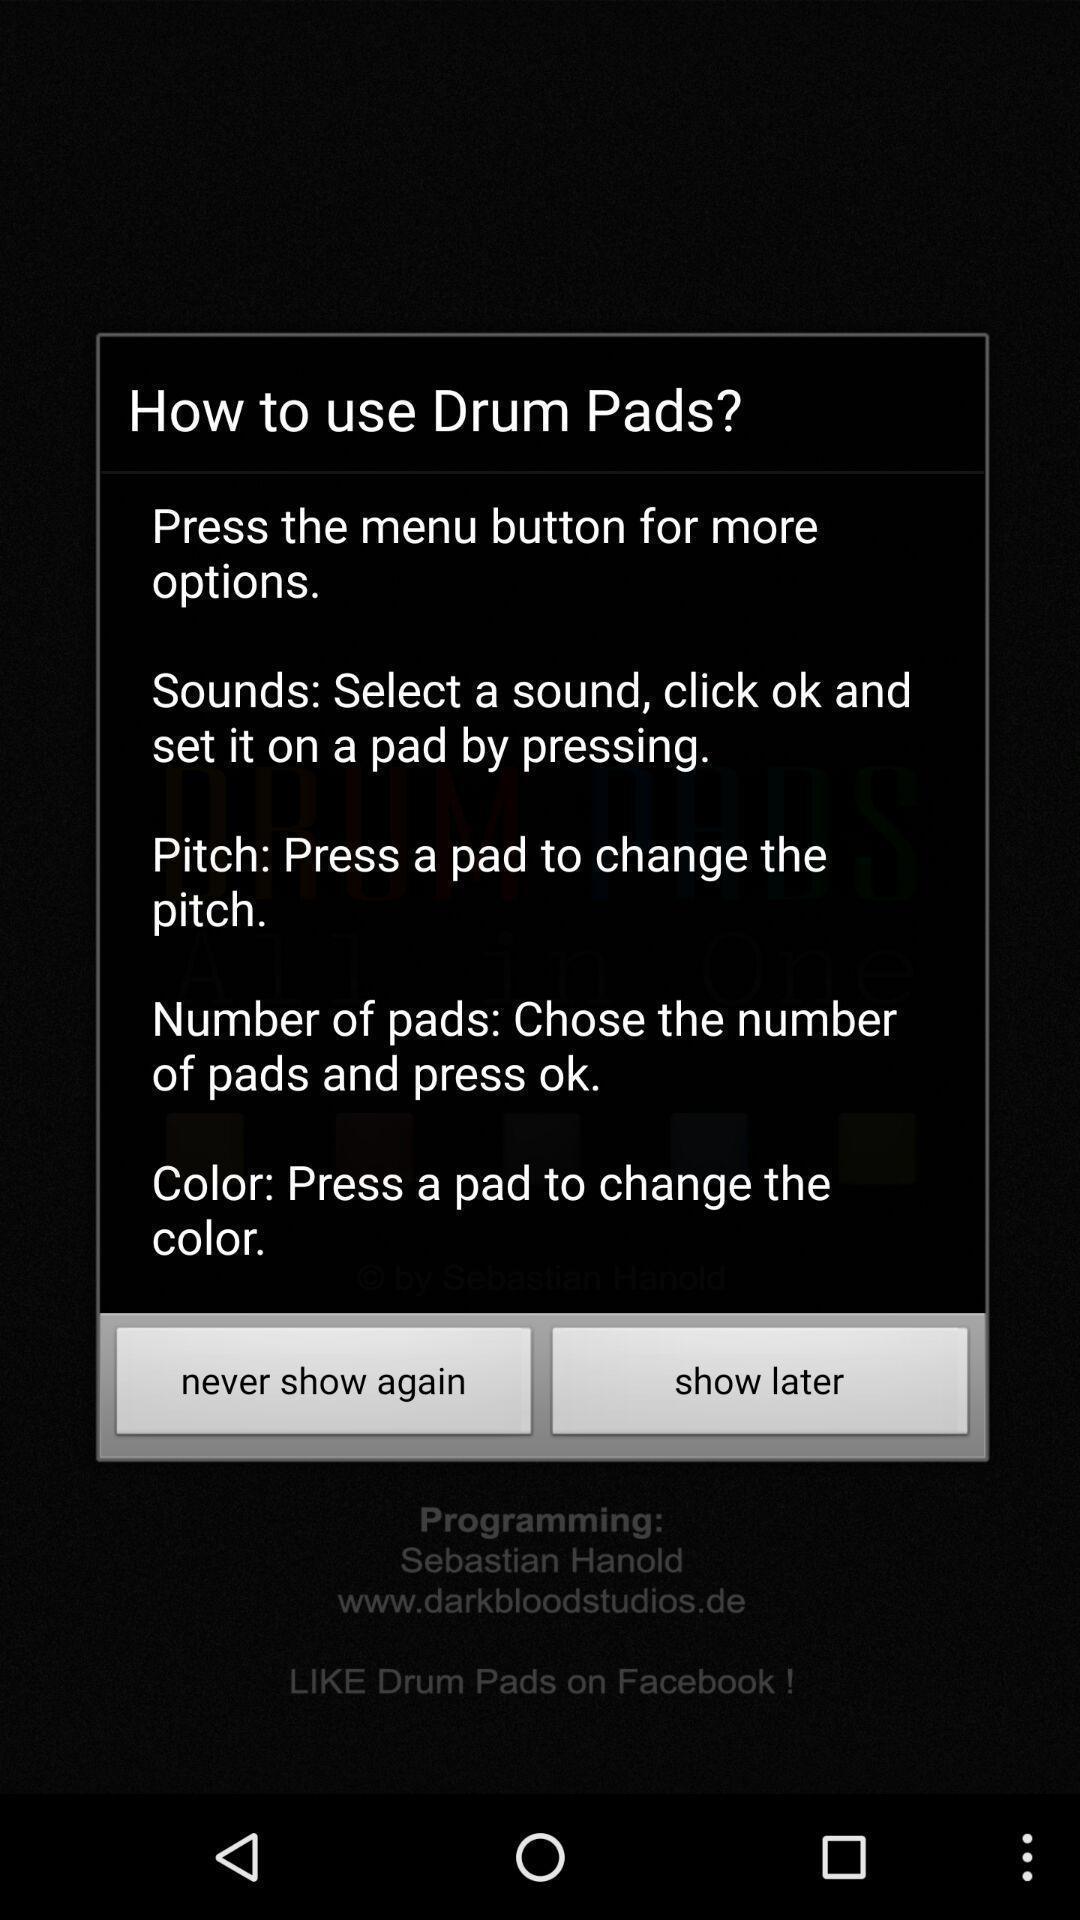Explain what's happening in this screen capture. Pop-up shows information about an app. 